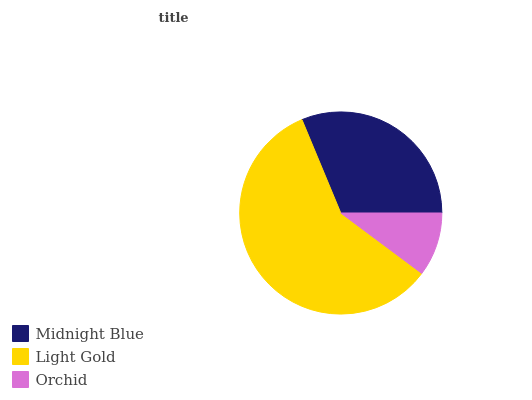Is Orchid the minimum?
Answer yes or no. Yes. Is Light Gold the maximum?
Answer yes or no. Yes. Is Light Gold the minimum?
Answer yes or no. No. Is Orchid the maximum?
Answer yes or no. No. Is Light Gold greater than Orchid?
Answer yes or no. Yes. Is Orchid less than Light Gold?
Answer yes or no. Yes. Is Orchid greater than Light Gold?
Answer yes or no. No. Is Light Gold less than Orchid?
Answer yes or no. No. Is Midnight Blue the high median?
Answer yes or no. Yes. Is Midnight Blue the low median?
Answer yes or no. Yes. Is Light Gold the high median?
Answer yes or no. No. Is Orchid the low median?
Answer yes or no. No. 